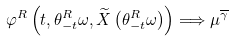<formula> <loc_0><loc_0><loc_500><loc_500>\varphi ^ { R } \left ( t , \theta ^ { R } _ { - t } \omega , \widetilde { X } \left ( \theta ^ { R } _ { - t } \omega \right ) \right ) \Longrightarrow \mu ^ { \overline { \gamma } }</formula> 